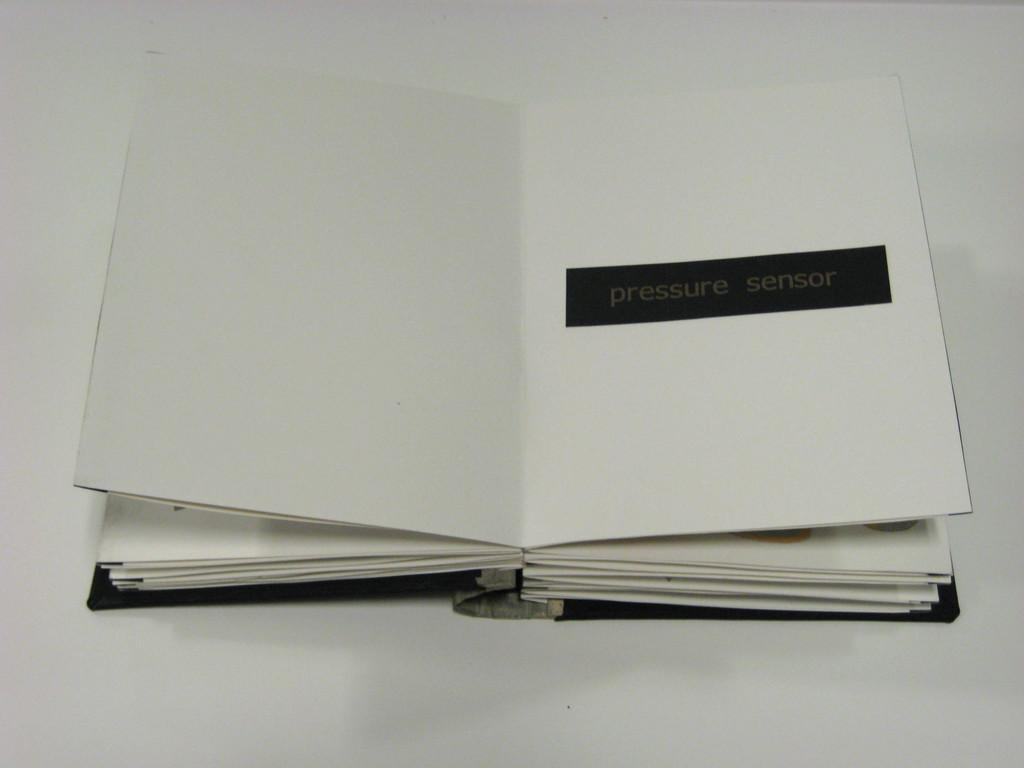<image>
Provide a brief description of the given image. An open book with the title of Pressure Sensor on it. 